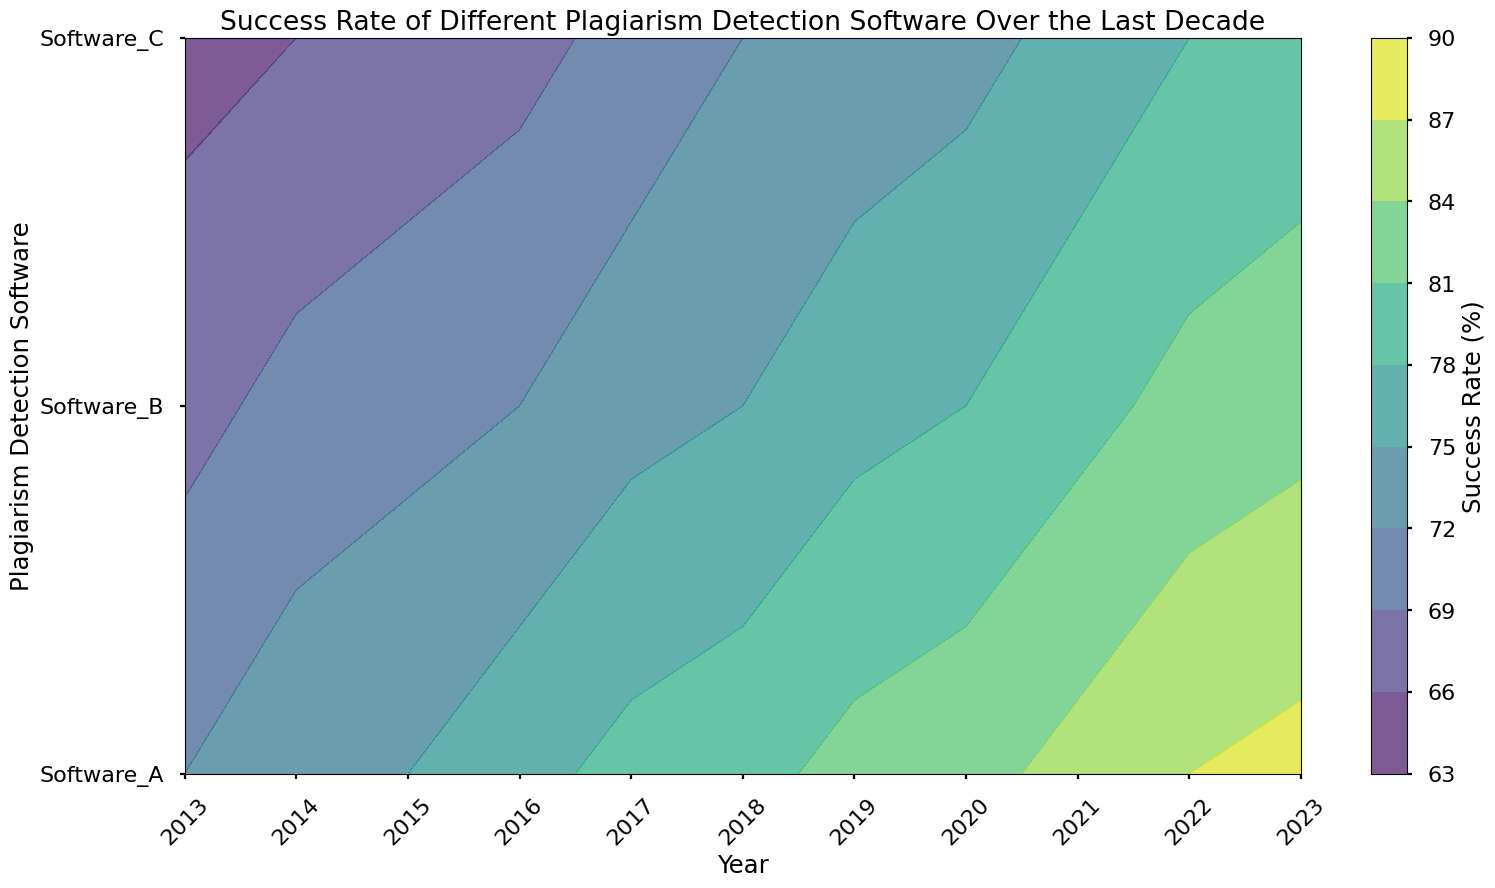What year did Software_C reach a success rate of 70%? To find when Software_C reached a success rate of 70%, locate the line representing Software_C and look for the area or contour touching the 70% success rate line. Observe the corresponding year on the x-axis.
Answer: 2017 Which software had the highest success rate in 2019? For the highest success rate in 2019, compare the y-values for the software at the year 2019 on the x-axis and identify the highest contour level.
Answer: Software_A What is the average success rate for Software_B from 2013 to 2016? Calculate the average success rate for Software_B by summing rates from 2013 to 2016 (68, 70, 71, 72) and dividing by 4. (68 + 70 + 71 + 72) / 4 = 70.25
Answer: 70.25 Which software showed the greatest improvement in success rate between 2015 and 2016? Identify the year 2015 and 2016 on the x-axis and compare success rates for all three software to determine the one with the highest increase. For Software_A: 77 - 75 = 2, Software_B: 72 - 71 = 1, Software_C: 68 - 67 = 1
Answer: Software_A In which year did Software_B achieve a success rate that equaled the success rate of Software_A in 2017? Find the success rate of Software_A in 2017, which is 79%. Then look for the year in which Software_B reached approximately 79% in the contour plot.
Answer: 2021 What was the color range corresponding to a success rate of 80% on the contour plot? Identify the color that corresponds to the 80% line on the colorbar, noting the range this color occupies on the plot.
Answer: Greenish-blue How much did Software_C's success rate improve from 2020 to 2023? Subtract the success rate of Software_C in 2020 from its success rate in 2023 (79 - 74).
Answer: 5 Which year shows the smallest difference in success rates among all three software? Examine each year's difference in successful rates among the software by comparing the smallest gap in the contour lines.
Answer: 2015 By how much did the success rate of Software_A increase from 2013 to 2023? Subtract the success rate of Software_A in 2013 from its success rate in 2023 (88 - 72).
Answer: 16 Which software consistently showed the lowest success rate every year? Identify the software line that consistently appears lowest each year on the y-axis positioning of the contours.
Answer: Software_C 